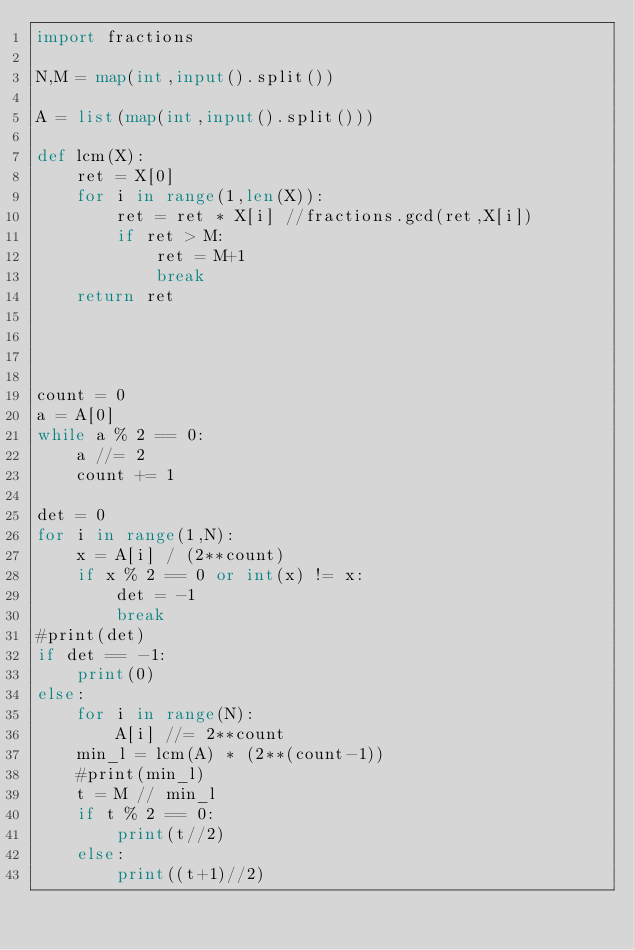<code> <loc_0><loc_0><loc_500><loc_500><_Python_>import fractions

N,M = map(int,input().split())

A = list(map(int,input().split()))

def lcm(X):
    ret = X[0]
    for i in range(1,len(X)):
        ret = ret * X[i] //fractions.gcd(ret,X[i])
        if ret > M:
            ret = M+1
            break
    return ret




count = 0
a = A[0]
while a % 2 == 0:
    a //= 2
    count += 1

det = 0
for i in range(1,N):
    x = A[i] / (2**count)
    if x % 2 == 0 or int(x) != x:
        det = -1
        break
#print(det)
if det == -1:
    print(0)
else:
    for i in range(N):
        A[i] //= 2**count
    min_l = lcm(A) * (2**(count-1))
    #print(min_l)
    t = M // min_l
    if t % 2 == 0:
        print(t//2)
    else:
        print((t+1)//2)</code> 